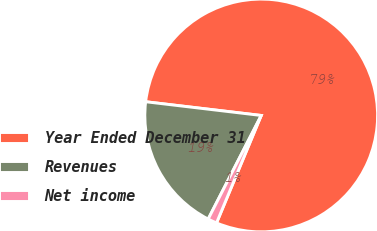Convert chart. <chart><loc_0><loc_0><loc_500><loc_500><pie_chart><fcel>Year Ended December 31<fcel>Revenues<fcel>Net income<nl><fcel>79.39%<fcel>19.35%<fcel>1.26%<nl></chart> 